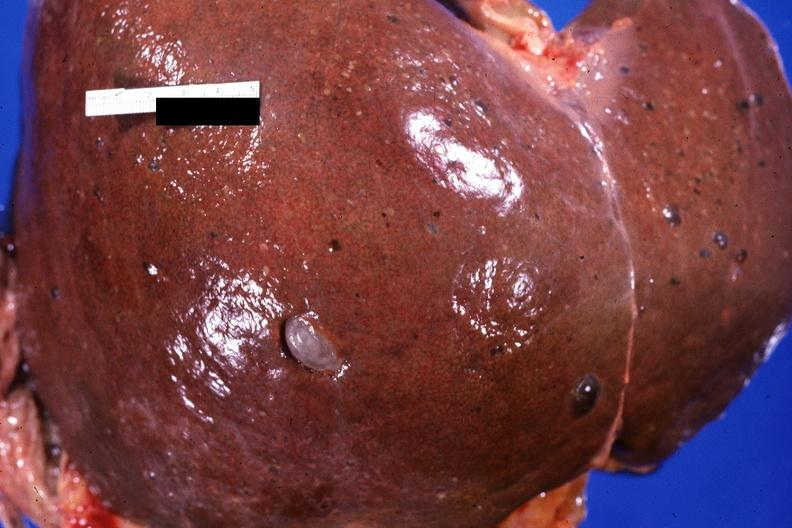s endometrial polyp present?
Answer the question using a single word or phrase. No 